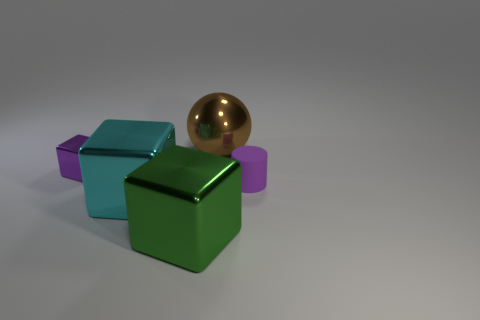Do the cyan shiny cube on the left side of the brown metallic object and the cylinder have the same size?
Offer a terse response. No. There is a purple thing in front of the purple thing that is behind the tiny object that is right of the tiny purple metallic block; what size is it?
Ensure brevity in your answer.  Small. There is a purple metallic object that is the same shape as the cyan thing; what is its size?
Provide a short and direct response. Small. Is there anything else that has the same color as the matte cylinder?
Keep it short and to the point. Yes. What number of objects are yellow cylinders or brown balls?
Offer a terse response. 1. Is there a cyan cube that has the same size as the purple matte cylinder?
Offer a terse response. No. What shape is the large cyan shiny thing?
Your response must be concise. Cube. Is the number of big objects that are in front of the purple cylinder greater than the number of small cubes that are to the right of the big brown metal thing?
Ensure brevity in your answer.  Yes. Does the object that is left of the big cyan metallic cube have the same color as the small object right of the brown thing?
Give a very brief answer. Yes. There is a object that is the same size as the purple cylinder; what is its shape?
Keep it short and to the point. Cube. 